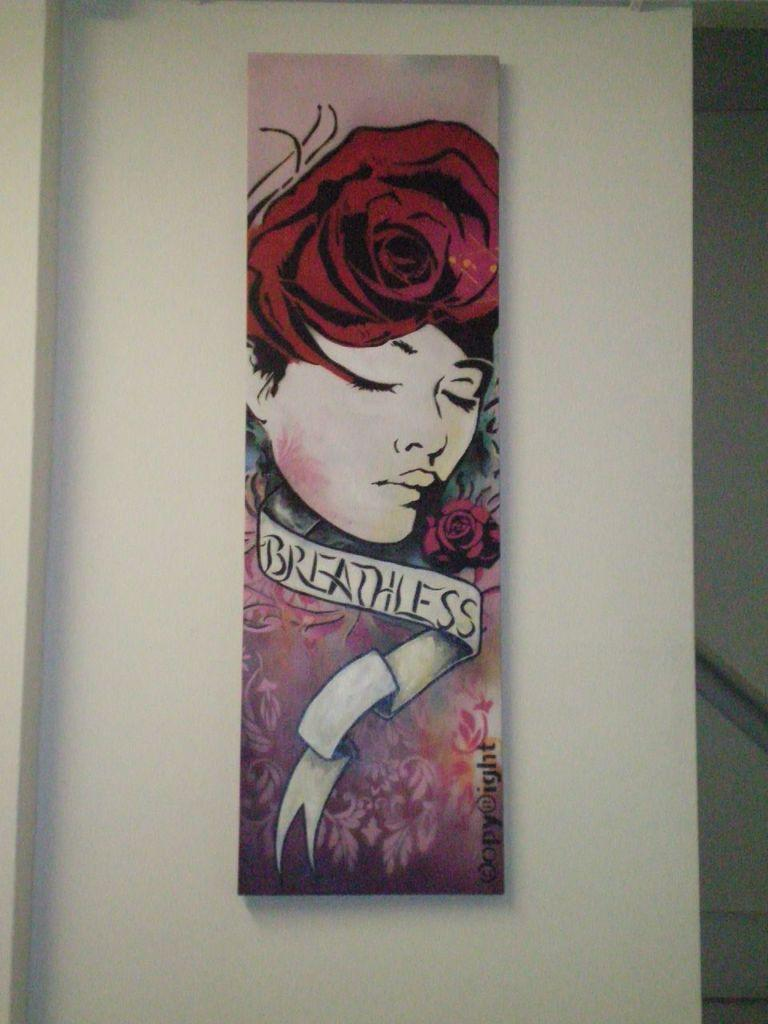What object in the image contains a painting? The photo frame in the image contains a painting of a woman. What is the subject of the painting in the photo frame? The painting in the photo frame depicts a woman. Is there any text visible in the image? Yes, there is writing on the photo frame or the wall. What color is the wall in the image? The wall in the image is white. How many pigs are visible in the image? There are no pigs present in the image. Is there a crown on the woman's head in the painting? The facts provided do not mention a crown, so we cannot determine if there is one in the painting. --- Facts: 1. There is a person sitting on a chair in the image. 2. The person is holding a book. 3. The book has a red cover. 4. There is a table next to the chair. 5. The table has a lamp on it. Absurd Topics: parrot, bicycle, ocean Conversation: What is the person in the image doing? The person in the image is sitting on a chair. What object is the person holding? The person is holding a book. What color is the book's cover? The book has a red cover. What is on the table next to the chair? There is a lamp on the table. Reasoning: Let's think step by step in order to produce the conversation. We start by identifying the main subject in the image, which is the person sitting on a chair. Then, we expand the conversation to include details about the object the person is holding (a book) and the color of the book's cover. Finally, we describe the table and its contents to provide a sense of the overall setting. Absurd Question/Answer: Can you see any parrots flying over the ocean in the image? There is no mention of parrots or an ocean in the image, so we cannot determine if they are present. Is the person riding a bicycle in the image? The facts provided do not mention a bicycle, so we cannot determine if the person is riding one. 